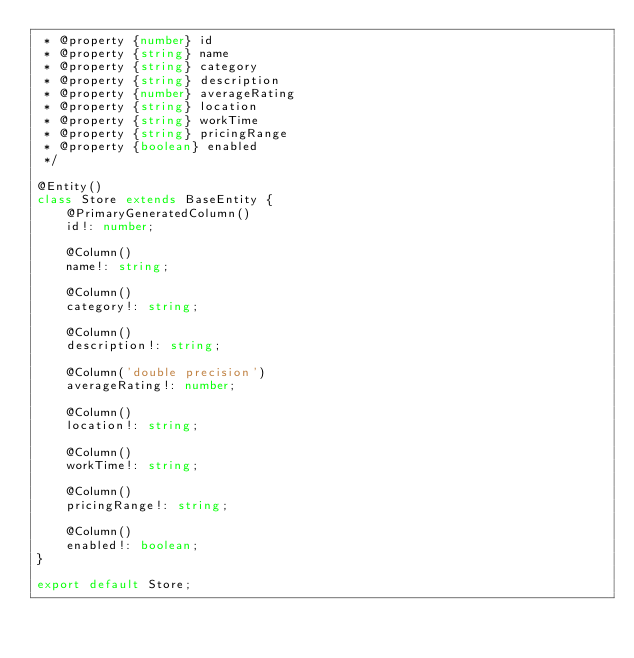Convert code to text. <code><loc_0><loc_0><loc_500><loc_500><_TypeScript_> * @property {number} id
 * @property {string} name
 * @property {string} category
 * @property {string} description
 * @property {number} averageRating
 * @property {string} location
 * @property {string} workTime
 * @property {string} pricingRange
 * @property {boolean} enabled
 */

@Entity()
class Store extends BaseEntity {
    @PrimaryGeneratedColumn()
    id!: number;

    @Column()
    name!: string;

    @Column()
    category!: string;

    @Column()
    description!: string;

    @Column('double precision')
    averageRating!: number;

    @Column()
    location!: string;

    @Column()
    workTime!: string;

    @Column()
    pricingRange!: string;

    @Column()
    enabled!: boolean;
}

export default Store;
</code> 